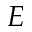Convert formula to latex. <formula><loc_0><loc_0><loc_500><loc_500>E</formula> 